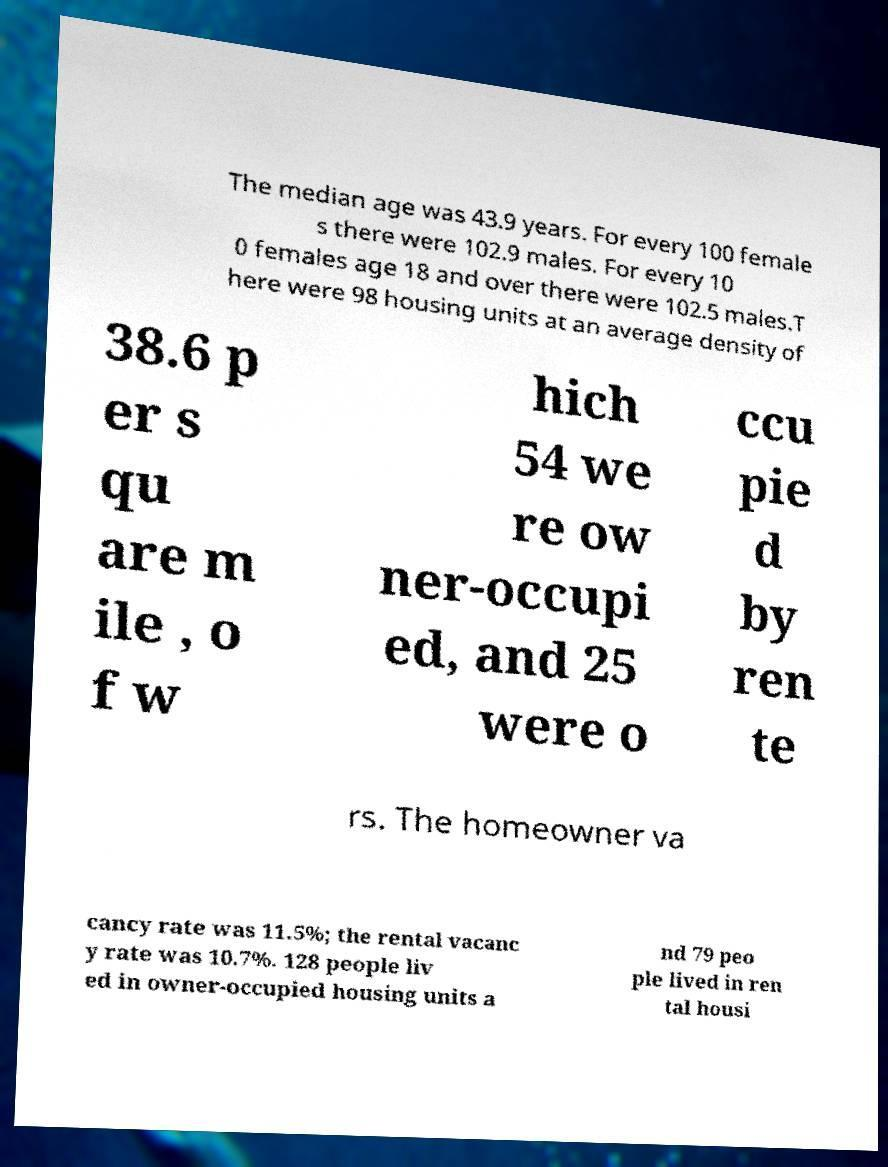There's text embedded in this image that I need extracted. Can you transcribe it verbatim? The median age was 43.9 years. For every 100 female s there were 102.9 males. For every 10 0 females age 18 and over there were 102.5 males.T here were 98 housing units at an average density of 38.6 p er s qu are m ile , o f w hich 54 we re ow ner-occupi ed, and 25 were o ccu pie d by ren te rs. The homeowner va cancy rate was 11.5%; the rental vacanc y rate was 10.7%. 128 people liv ed in owner-occupied housing units a nd 79 peo ple lived in ren tal housi 